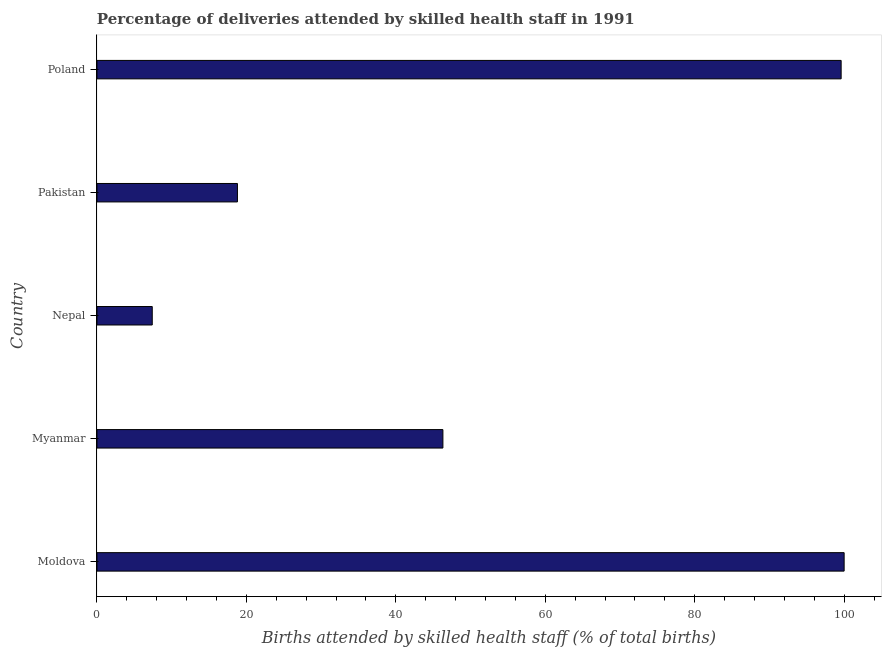Does the graph contain any zero values?
Provide a succinct answer. No. Does the graph contain grids?
Provide a short and direct response. No. What is the title of the graph?
Offer a very short reply. Percentage of deliveries attended by skilled health staff in 1991. What is the label or title of the X-axis?
Ensure brevity in your answer.  Births attended by skilled health staff (% of total births). What is the label or title of the Y-axis?
Provide a short and direct response. Country. Across all countries, what is the maximum number of births attended by skilled health staff?
Give a very brief answer. 100. In which country was the number of births attended by skilled health staff maximum?
Keep it short and to the point. Moldova. In which country was the number of births attended by skilled health staff minimum?
Offer a terse response. Nepal. What is the sum of the number of births attended by skilled health staff?
Provide a succinct answer. 272.1. What is the difference between the number of births attended by skilled health staff in Myanmar and Poland?
Provide a succinct answer. -53.3. What is the average number of births attended by skilled health staff per country?
Offer a terse response. 54.42. What is the median number of births attended by skilled health staff?
Give a very brief answer. 46.3. In how many countries, is the number of births attended by skilled health staff greater than 8 %?
Ensure brevity in your answer.  4. What is the ratio of the number of births attended by skilled health staff in Myanmar to that in Pakistan?
Ensure brevity in your answer.  2.46. Is the difference between the number of births attended by skilled health staff in Moldova and Myanmar greater than the difference between any two countries?
Your response must be concise. No. Is the sum of the number of births attended by skilled health staff in Nepal and Pakistan greater than the maximum number of births attended by skilled health staff across all countries?
Provide a succinct answer. No. What is the difference between the highest and the lowest number of births attended by skilled health staff?
Provide a succinct answer. 92.6. How many bars are there?
Ensure brevity in your answer.  5. Are all the bars in the graph horizontal?
Your response must be concise. Yes. What is the difference between two consecutive major ticks on the X-axis?
Offer a very short reply. 20. Are the values on the major ticks of X-axis written in scientific E-notation?
Make the answer very short. No. What is the Births attended by skilled health staff (% of total births) in Moldova?
Ensure brevity in your answer.  100. What is the Births attended by skilled health staff (% of total births) in Myanmar?
Offer a terse response. 46.3. What is the Births attended by skilled health staff (% of total births) in Nepal?
Your response must be concise. 7.4. What is the Births attended by skilled health staff (% of total births) in Poland?
Give a very brief answer. 99.6. What is the difference between the Births attended by skilled health staff (% of total births) in Moldova and Myanmar?
Keep it short and to the point. 53.7. What is the difference between the Births attended by skilled health staff (% of total births) in Moldova and Nepal?
Offer a very short reply. 92.6. What is the difference between the Births attended by skilled health staff (% of total births) in Moldova and Pakistan?
Provide a succinct answer. 81.2. What is the difference between the Births attended by skilled health staff (% of total births) in Moldova and Poland?
Ensure brevity in your answer.  0.4. What is the difference between the Births attended by skilled health staff (% of total births) in Myanmar and Nepal?
Provide a short and direct response. 38.9. What is the difference between the Births attended by skilled health staff (% of total births) in Myanmar and Poland?
Your answer should be very brief. -53.3. What is the difference between the Births attended by skilled health staff (% of total births) in Nepal and Pakistan?
Your answer should be compact. -11.4. What is the difference between the Births attended by skilled health staff (% of total births) in Nepal and Poland?
Provide a succinct answer. -92.2. What is the difference between the Births attended by skilled health staff (% of total births) in Pakistan and Poland?
Your response must be concise. -80.8. What is the ratio of the Births attended by skilled health staff (% of total births) in Moldova to that in Myanmar?
Offer a very short reply. 2.16. What is the ratio of the Births attended by skilled health staff (% of total births) in Moldova to that in Nepal?
Your answer should be compact. 13.51. What is the ratio of the Births attended by skilled health staff (% of total births) in Moldova to that in Pakistan?
Offer a very short reply. 5.32. What is the ratio of the Births attended by skilled health staff (% of total births) in Myanmar to that in Nepal?
Your answer should be compact. 6.26. What is the ratio of the Births attended by skilled health staff (% of total births) in Myanmar to that in Pakistan?
Your answer should be compact. 2.46. What is the ratio of the Births attended by skilled health staff (% of total births) in Myanmar to that in Poland?
Offer a terse response. 0.47. What is the ratio of the Births attended by skilled health staff (% of total births) in Nepal to that in Pakistan?
Ensure brevity in your answer.  0.39. What is the ratio of the Births attended by skilled health staff (% of total births) in Nepal to that in Poland?
Keep it short and to the point. 0.07. What is the ratio of the Births attended by skilled health staff (% of total births) in Pakistan to that in Poland?
Offer a very short reply. 0.19. 